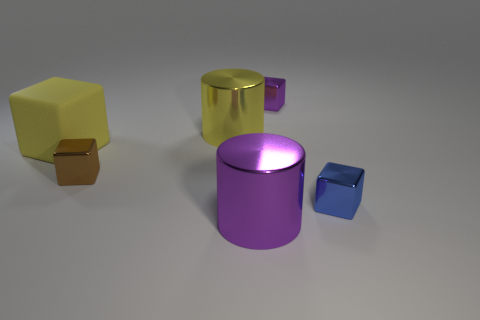The big cylinder behind the big object to the right of the large yellow shiny object is made of what material?
Offer a very short reply. Metal. Are there more tiny metal objects that are on the left side of the blue metallic thing than yellow rubber objects?
Keep it short and to the point. Yes. There is a tiny metal thing that is to the left of the big purple metal object; is it the same shape as the big yellow rubber thing?
Offer a terse response. Yes. Are there any other things that have the same material as the yellow cube?
Make the answer very short. No. What number of things are either brown metal cubes or tiny metallic cubes that are behind the brown shiny thing?
Keep it short and to the point. 2. There is a block that is both left of the big purple cylinder and on the right side of the yellow block; what size is it?
Your response must be concise. Small. Are there more yellow objects left of the small purple cube than yellow rubber things that are behind the matte thing?
Your answer should be compact. Yes. There is a large yellow metal object; is it the same shape as the purple metallic object that is in front of the large rubber object?
Make the answer very short. Yes. What number of other objects are there of the same shape as the small purple thing?
Offer a very short reply. 3. There is a metal object that is behind the yellow matte thing and left of the purple cylinder; what color is it?
Your answer should be very brief. Yellow. 